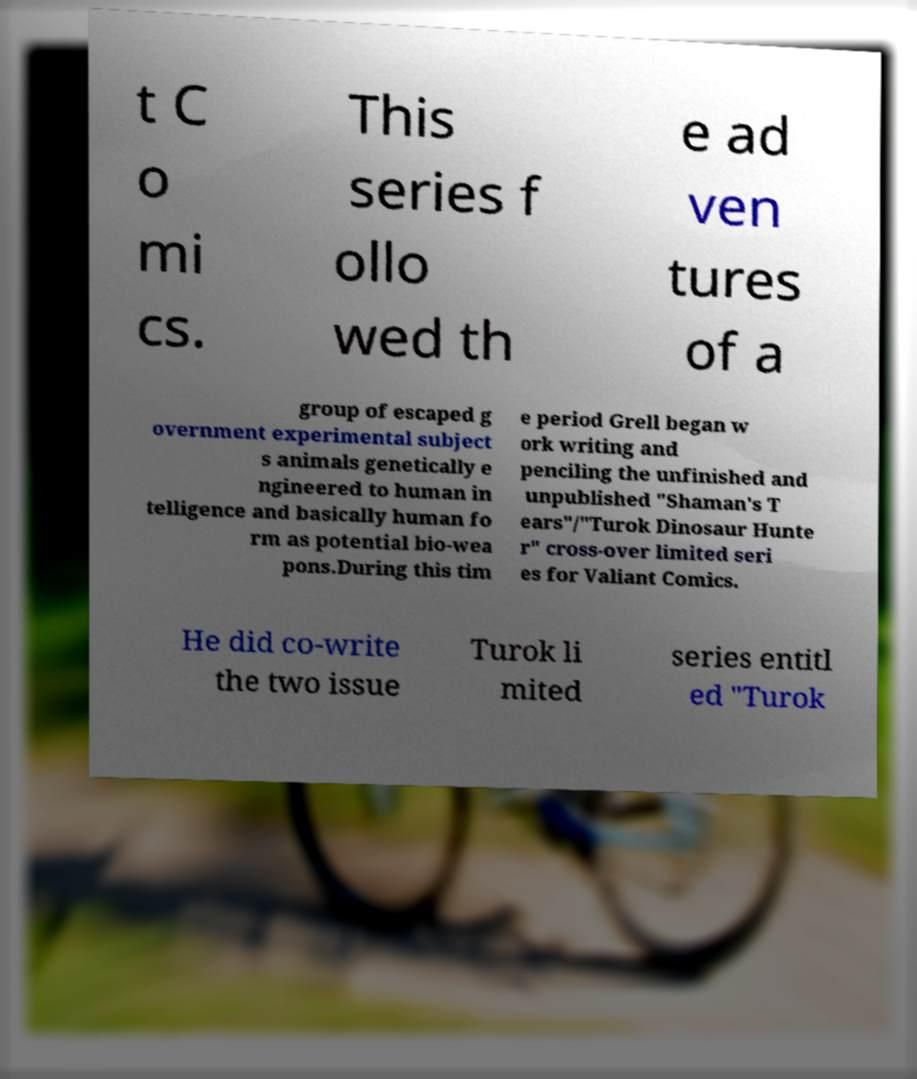I need the written content from this picture converted into text. Can you do that? t C o mi cs. This series f ollo wed th e ad ven tures of a group of escaped g overnment experimental subject s animals genetically e ngineered to human in telligence and basically human fo rm as potential bio-wea pons.During this tim e period Grell began w ork writing and penciling the unfinished and unpublished "Shaman's T ears"/"Turok Dinosaur Hunte r" cross-over limited seri es for Valiant Comics. He did co-write the two issue Turok li mited series entitl ed "Turok 